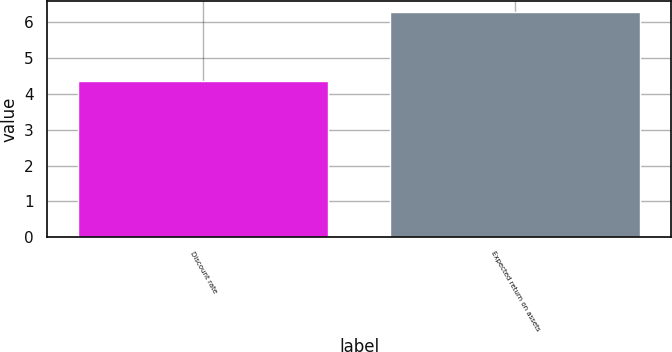Convert chart. <chart><loc_0><loc_0><loc_500><loc_500><bar_chart><fcel>Discount rate<fcel>Expected return on assets<nl><fcel>4.35<fcel>6.29<nl></chart> 